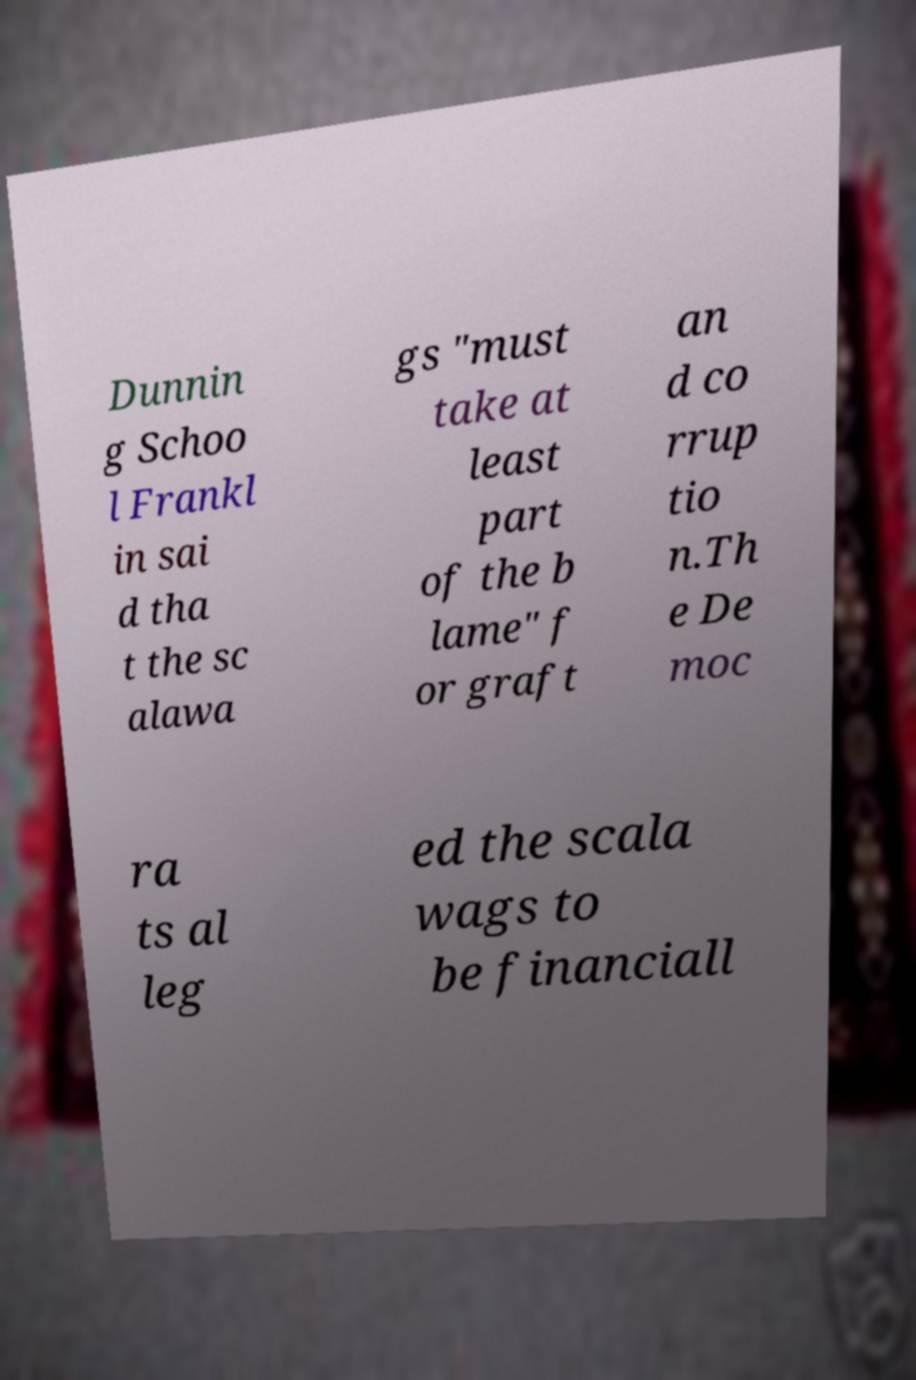Can you accurately transcribe the text from the provided image for me? Dunnin g Schoo l Frankl in sai d tha t the sc alawa gs "must take at least part of the b lame" f or graft an d co rrup tio n.Th e De moc ra ts al leg ed the scala wags to be financiall 